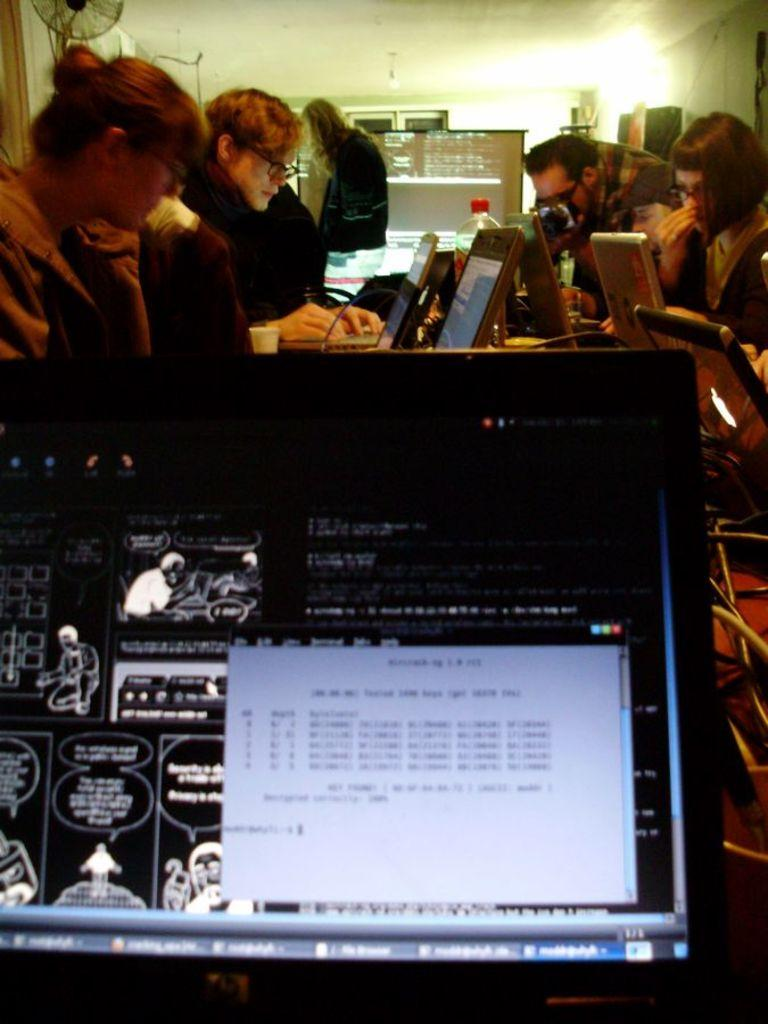How many people are in the image? There are people in the image, but the exact number is not specified. What are some of the people doing in the image? Some of the people are operating laptops in the image. What can be seen in the background of the image? In the background of the image, there is a screen, the ceiling, a fan, and other objects. Can you describe the objects visible in the background of the image? The objects visible in the background of the image include a screen, the ceiling, and a fan. What type of error message is displayed on the screen in the image? There is no mention of an error message on the screen in the image. 